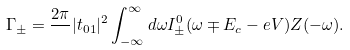<formula> <loc_0><loc_0><loc_500><loc_500>\Gamma _ { \pm } = \frac { 2 \pi } { } | t _ { 0 1 } | ^ { 2 } \int _ { - \infty } ^ { \infty } d \omega I ^ { 0 } _ { \pm } ( \omega \mp E _ { c } - e V ) Z ( - \omega ) .</formula> 